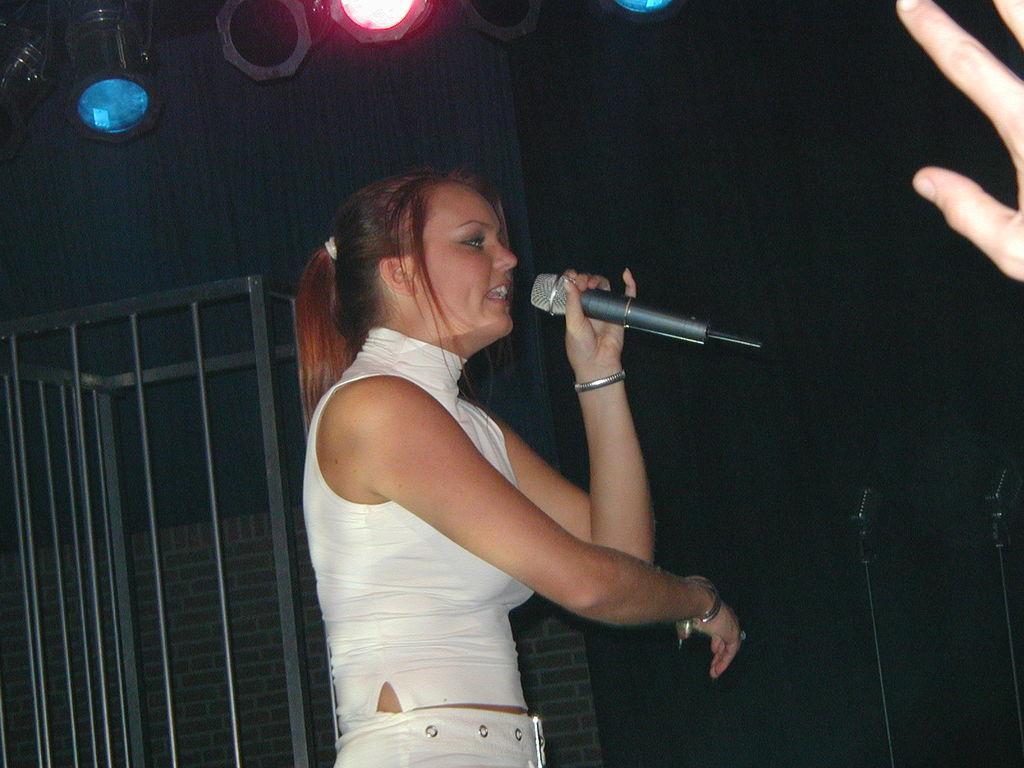Can you describe this image briefly? In this image I can see a person wearing white dress and holding a mic. To the right there are three fingers of the person. In the background there are lights and the rod. 